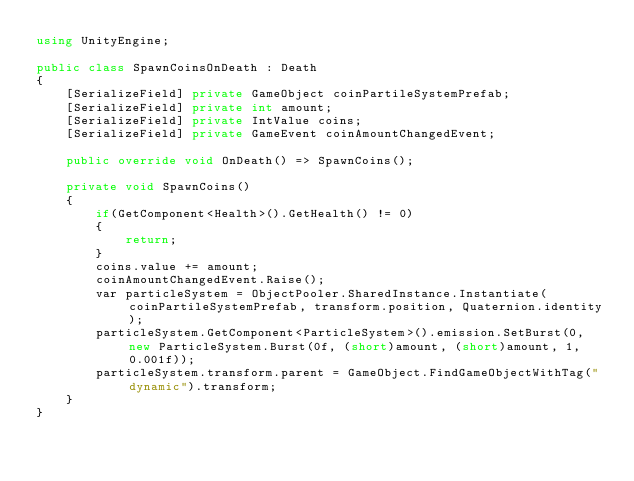<code> <loc_0><loc_0><loc_500><loc_500><_C#_>using UnityEngine;

public class SpawnCoinsOnDeath : Death
{
    [SerializeField] private GameObject coinPartileSystemPrefab;
    [SerializeField] private int amount;
    [SerializeField] private IntValue coins;
    [SerializeField] private GameEvent coinAmountChangedEvent;

    public override void OnDeath() => SpawnCoins();

    private void SpawnCoins()
    {
        if(GetComponent<Health>().GetHealth() != 0)
        {
            return;
        }
        coins.value += amount;
        coinAmountChangedEvent.Raise();
        var particleSystem = ObjectPooler.SharedInstance.Instantiate(coinPartileSystemPrefab, transform.position, Quaternion.identity);
        particleSystem.GetComponent<ParticleSystem>().emission.SetBurst(0, new ParticleSystem.Burst(0f, (short)amount, (short)amount, 1, 0.001f));
        particleSystem.transform.parent = GameObject.FindGameObjectWithTag("dynamic").transform;
    }
}
</code> 